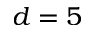Convert formula to latex. <formula><loc_0><loc_0><loc_500><loc_500>d = 5</formula> 